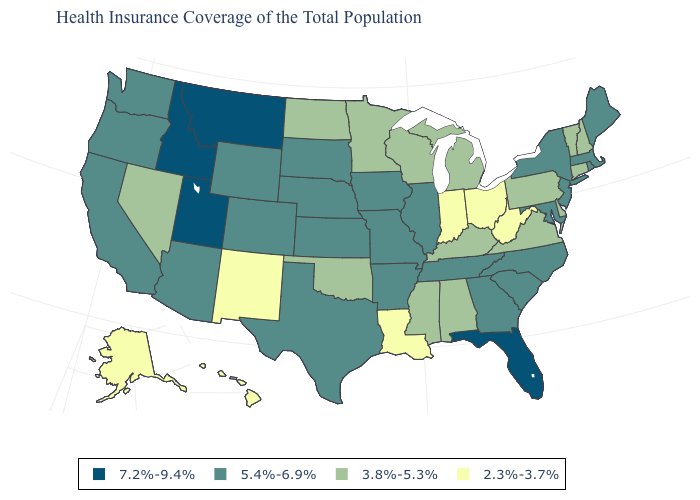Name the states that have a value in the range 3.8%-5.3%?
Give a very brief answer. Alabama, Connecticut, Delaware, Kentucky, Michigan, Minnesota, Mississippi, Nevada, New Hampshire, North Dakota, Oklahoma, Pennsylvania, Vermont, Virginia, Wisconsin. Does the first symbol in the legend represent the smallest category?
Answer briefly. No. What is the value of Massachusetts?
Keep it brief. 5.4%-6.9%. Does Louisiana have the lowest value in the South?
Quick response, please. Yes. Does Arkansas have the highest value in the South?
Answer briefly. No. Does Georgia have a lower value than Iowa?
Write a very short answer. No. Does Michigan have the same value as Maine?
Quick response, please. No. Name the states that have a value in the range 7.2%-9.4%?
Concise answer only. Florida, Idaho, Montana, Utah. Name the states that have a value in the range 2.3%-3.7%?
Write a very short answer. Alaska, Hawaii, Indiana, Louisiana, New Mexico, Ohio, West Virginia. Among the states that border Pennsylvania , does Delaware have the lowest value?
Concise answer only. No. Among the states that border Utah , does Colorado have the lowest value?
Be succinct. No. Does Connecticut have the highest value in the USA?
Quick response, please. No. Name the states that have a value in the range 3.8%-5.3%?
Write a very short answer. Alabama, Connecticut, Delaware, Kentucky, Michigan, Minnesota, Mississippi, Nevada, New Hampshire, North Dakota, Oklahoma, Pennsylvania, Vermont, Virginia, Wisconsin. How many symbols are there in the legend?
Be succinct. 4. What is the value of Maine?
Concise answer only. 5.4%-6.9%. 